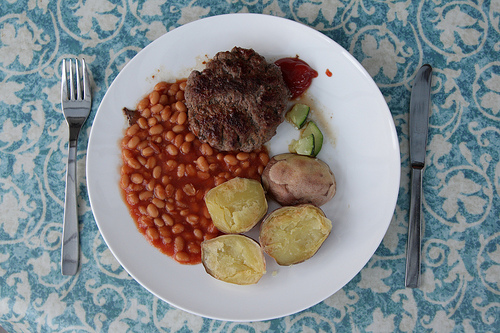<image>
Is there a potato on the beans? Yes. Looking at the image, I can see the potato is positioned on top of the beans, with the beans providing support. 